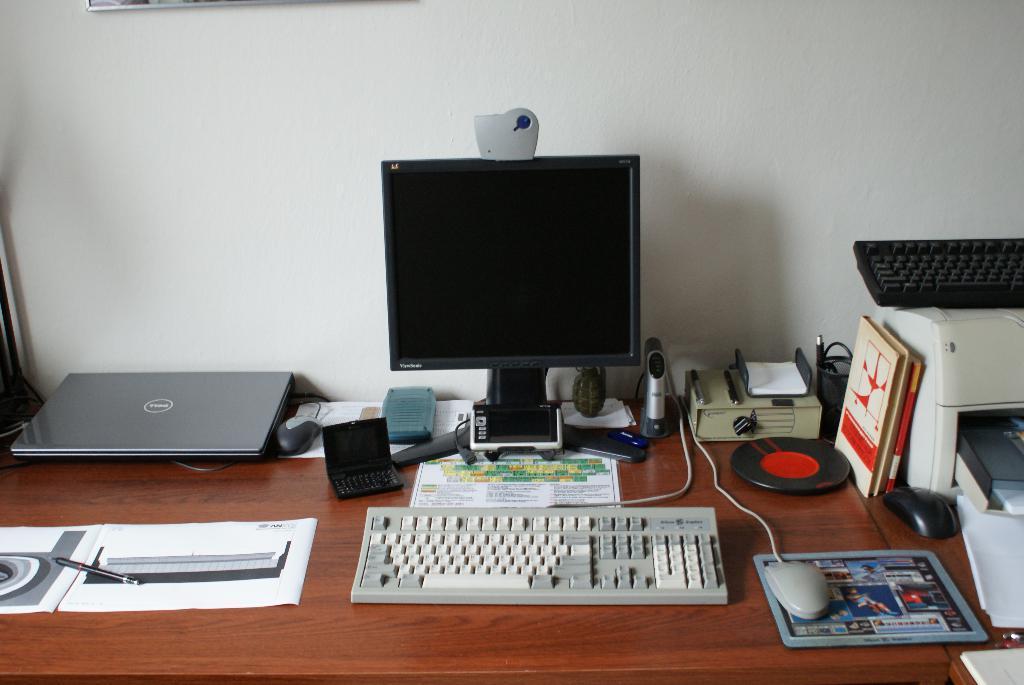Describe this image in one or two sentences. In this picture we can see a monitor, a keyboard, a mouse and mousepad, on the right side of the picture we can see printer, on the left side of the picture there is a laptop, we can see another mouse hear, in the background there is a wall and also we can see a paper and pen here. 